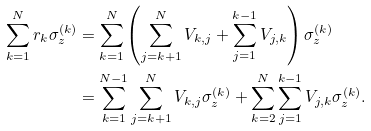<formula> <loc_0><loc_0><loc_500><loc_500>\sum ^ { N } _ { k = 1 } r _ { k } \sigma ^ { ( k ) } _ { z } & = \sum ^ { N } _ { k = 1 } \left ( \sum ^ { N } _ { j = k + 1 } V _ { k , j } + \sum ^ { k - 1 } _ { j = 1 } V _ { j , k } \right ) \sigma ^ { ( k ) } _ { z } \\ & = \sum ^ { N - 1 } _ { k = 1 } \sum ^ { N } _ { j = k + 1 } V _ { k , j } \sigma ^ { ( k ) } _ { z } + \sum ^ { N } _ { k = 2 } \sum ^ { k - 1 } _ { j = 1 } V _ { j , k } \sigma ^ { ( k ) } _ { z } .</formula> 